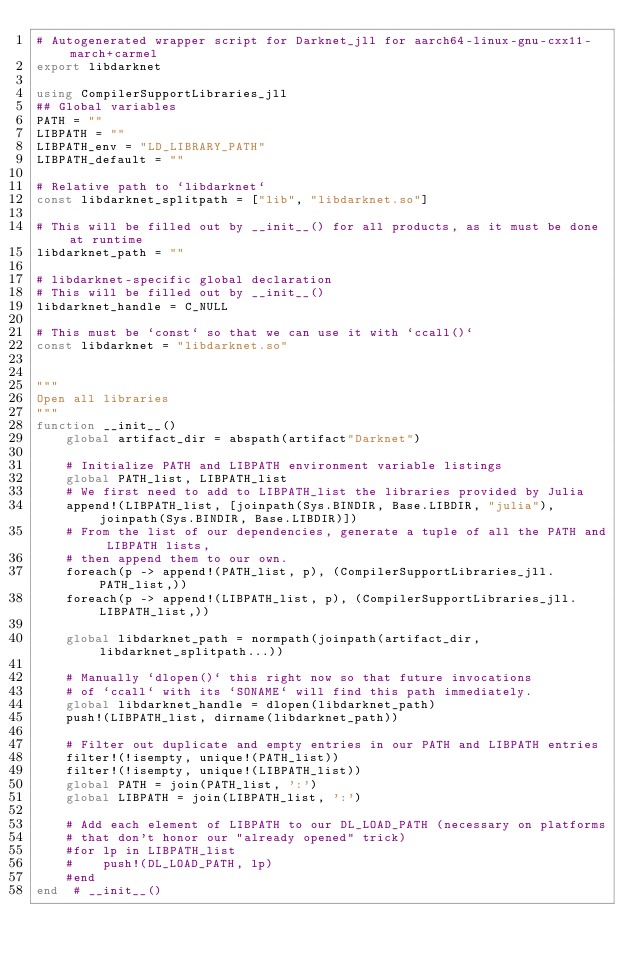<code> <loc_0><loc_0><loc_500><loc_500><_Julia_># Autogenerated wrapper script for Darknet_jll for aarch64-linux-gnu-cxx11-march+carmel
export libdarknet

using CompilerSupportLibraries_jll
## Global variables
PATH = ""
LIBPATH = ""
LIBPATH_env = "LD_LIBRARY_PATH"
LIBPATH_default = ""

# Relative path to `libdarknet`
const libdarknet_splitpath = ["lib", "libdarknet.so"]

# This will be filled out by __init__() for all products, as it must be done at runtime
libdarknet_path = ""

# libdarknet-specific global declaration
# This will be filled out by __init__()
libdarknet_handle = C_NULL

# This must be `const` so that we can use it with `ccall()`
const libdarknet = "libdarknet.so"


"""
Open all libraries
"""
function __init__()
    global artifact_dir = abspath(artifact"Darknet")

    # Initialize PATH and LIBPATH environment variable listings
    global PATH_list, LIBPATH_list
    # We first need to add to LIBPATH_list the libraries provided by Julia
    append!(LIBPATH_list, [joinpath(Sys.BINDIR, Base.LIBDIR, "julia"), joinpath(Sys.BINDIR, Base.LIBDIR)])
    # From the list of our dependencies, generate a tuple of all the PATH and LIBPATH lists,
    # then append them to our own.
    foreach(p -> append!(PATH_list, p), (CompilerSupportLibraries_jll.PATH_list,))
    foreach(p -> append!(LIBPATH_list, p), (CompilerSupportLibraries_jll.LIBPATH_list,))

    global libdarknet_path = normpath(joinpath(artifact_dir, libdarknet_splitpath...))

    # Manually `dlopen()` this right now so that future invocations
    # of `ccall` with its `SONAME` will find this path immediately.
    global libdarknet_handle = dlopen(libdarknet_path)
    push!(LIBPATH_list, dirname(libdarknet_path))

    # Filter out duplicate and empty entries in our PATH and LIBPATH entries
    filter!(!isempty, unique!(PATH_list))
    filter!(!isempty, unique!(LIBPATH_list))
    global PATH = join(PATH_list, ':')
    global LIBPATH = join(LIBPATH_list, ':')

    # Add each element of LIBPATH to our DL_LOAD_PATH (necessary on platforms
    # that don't honor our "already opened" trick)
    #for lp in LIBPATH_list
    #    push!(DL_LOAD_PATH, lp)
    #end
end  # __init__()

</code> 